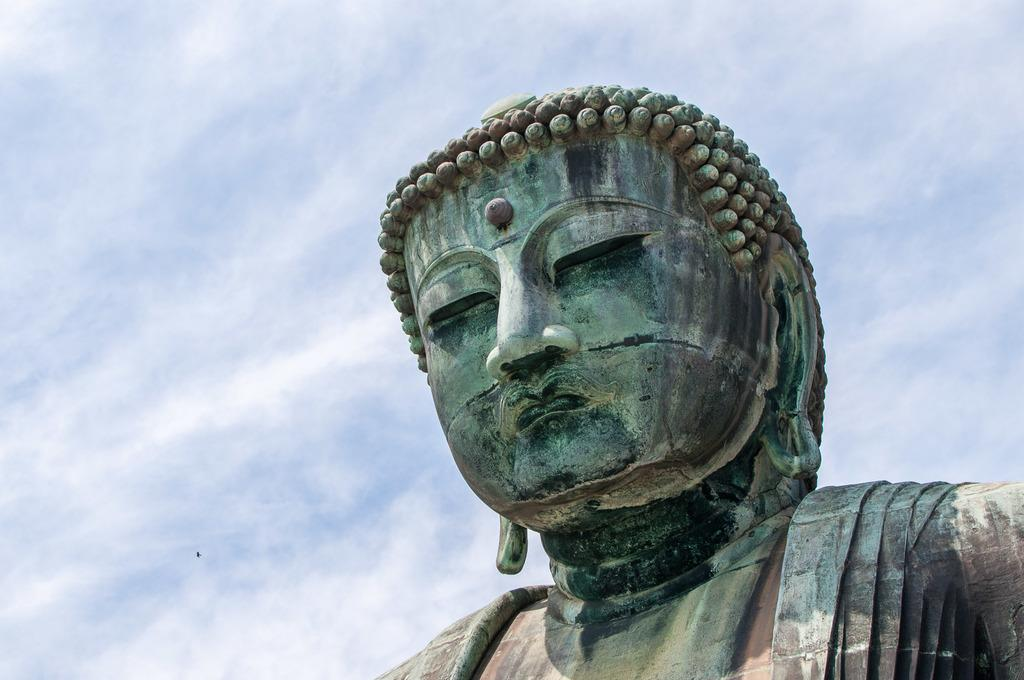What is the main subject of the image? There is a statue in the image. What can be seen in the background of the image? The sky is visible in the background of the image. What type of exchange is taking place between the statue and the sky in the image? There is no exchange between the statue and the sky in the image; the statue is a stationary object, and the sky is a natural background element. 